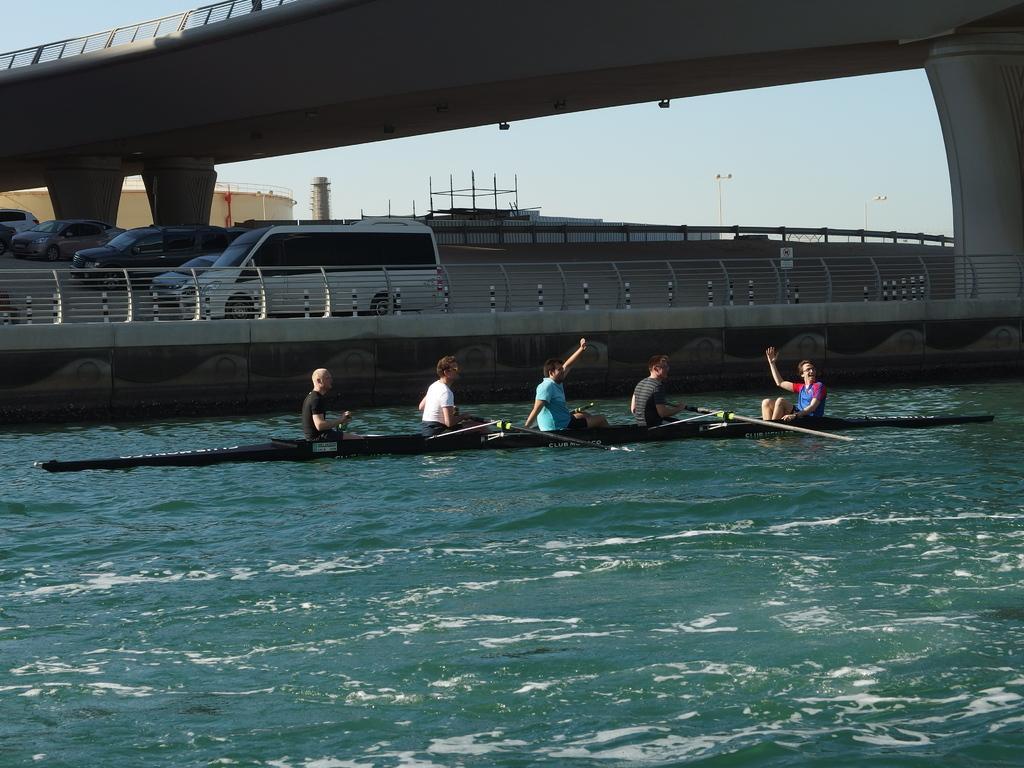In one or two sentences, can you explain what this image depicts? In this image, we can see few people are sailing a boat on the water. Background we can see vehicles, road, railings, poles, pillars, bridge and sky. 